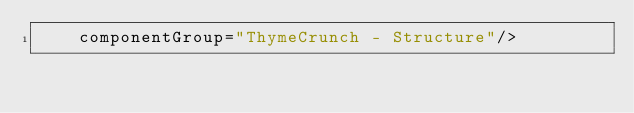Convert code to text. <code><loc_0><loc_0><loc_500><loc_500><_XML_>    componentGroup="ThymeCrunch - Structure"/>
</code> 